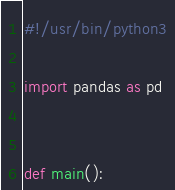Convert code to text. <code><loc_0><loc_0><loc_500><loc_500><_Python_>#!/usr/bin/python3

import pandas as pd


def main():</code> 